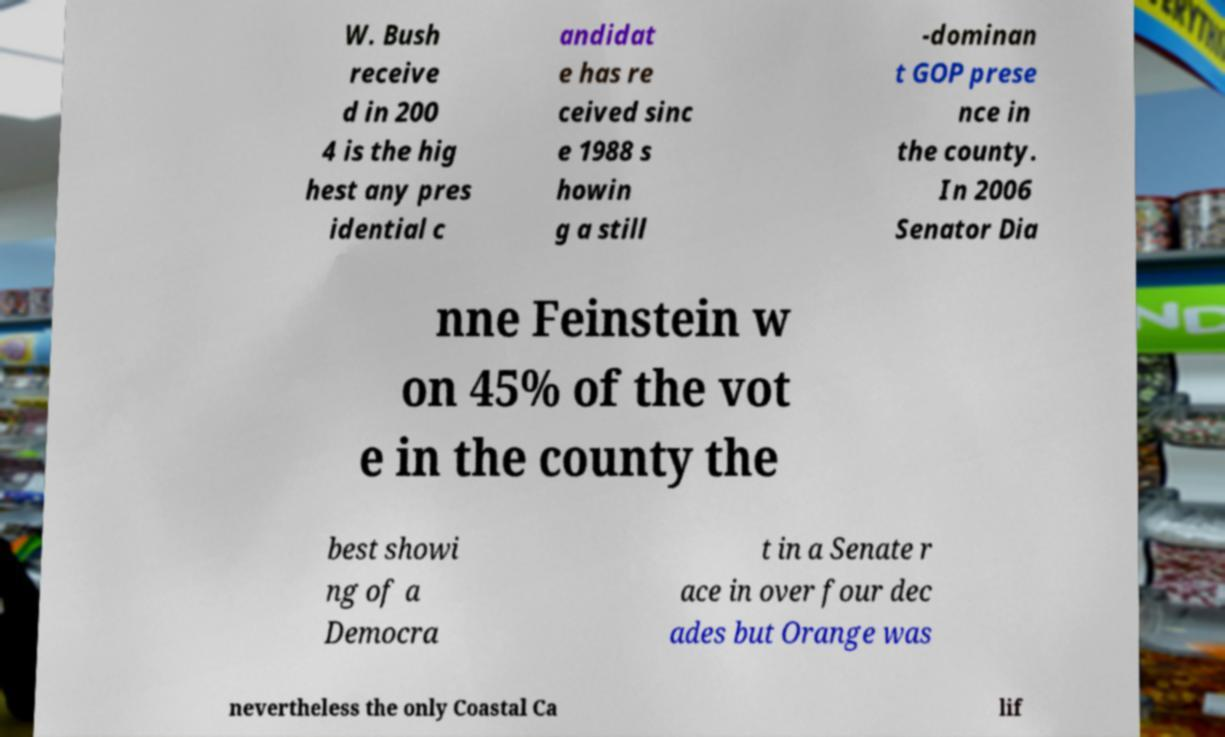Please read and relay the text visible in this image. What does it say? W. Bush receive d in 200 4 is the hig hest any pres idential c andidat e has re ceived sinc e 1988 s howin g a still -dominan t GOP prese nce in the county. In 2006 Senator Dia nne Feinstein w on 45% of the vot e in the county the best showi ng of a Democra t in a Senate r ace in over four dec ades but Orange was nevertheless the only Coastal Ca lif 